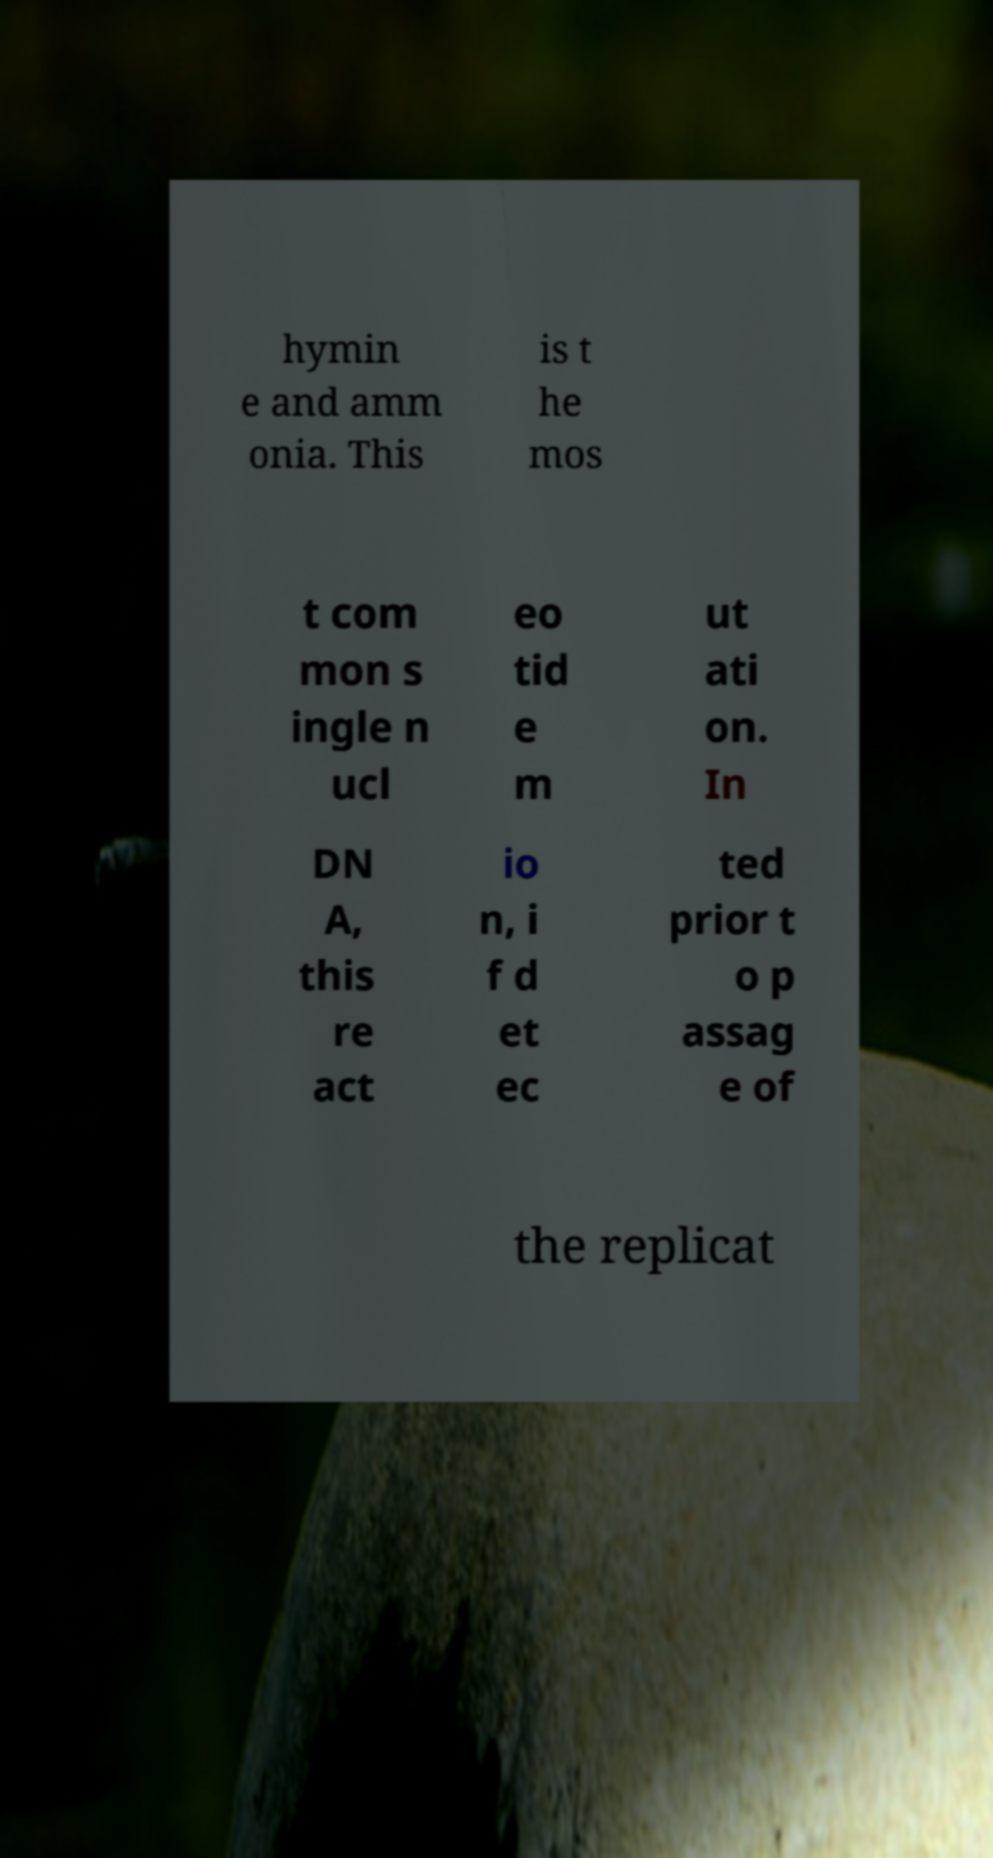Please read and relay the text visible in this image. What does it say? hymin e and amm onia. This is t he mos t com mon s ingle n ucl eo tid e m ut ati on. In DN A, this re act io n, i f d et ec ted prior t o p assag e of the replicat 